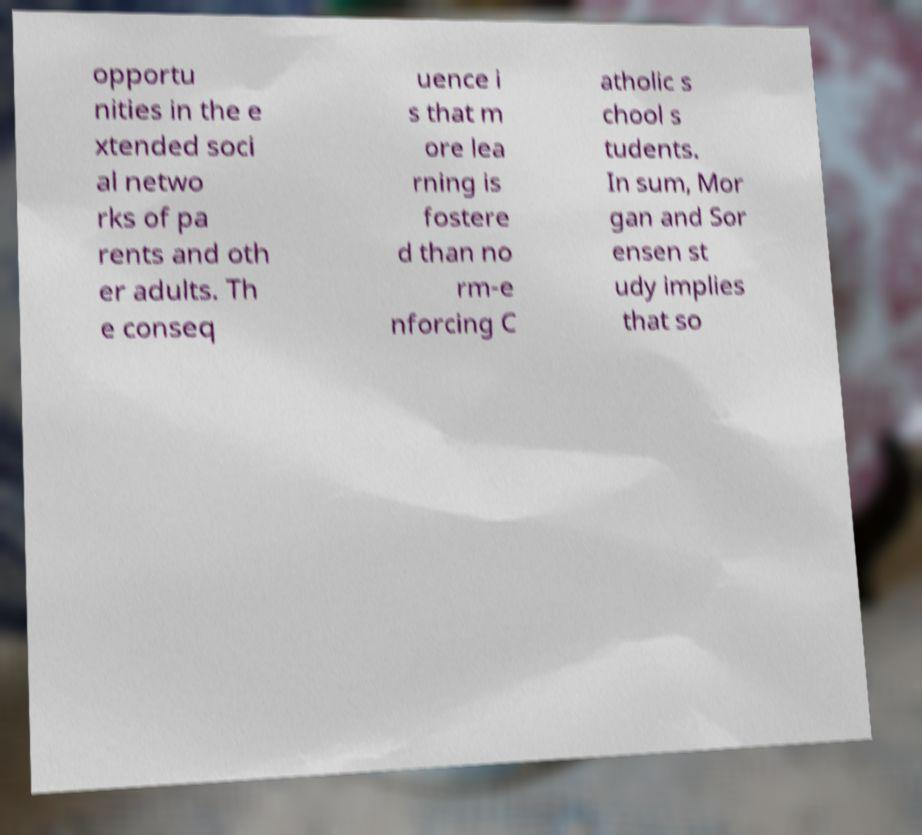Could you extract and type out the text from this image? opportu nities in the e xtended soci al netwo rks of pa rents and oth er adults. Th e conseq uence i s that m ore lea rning is fostere d than no rm-e nforcing C atholic s chool s tudents. In sum, Mor gan and Sor ensen st udy implies that so 